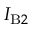Convert formula to latex. <formula><loc_0><loc_0><loc_500><loc_500>I _ { B 2 }</formula> 